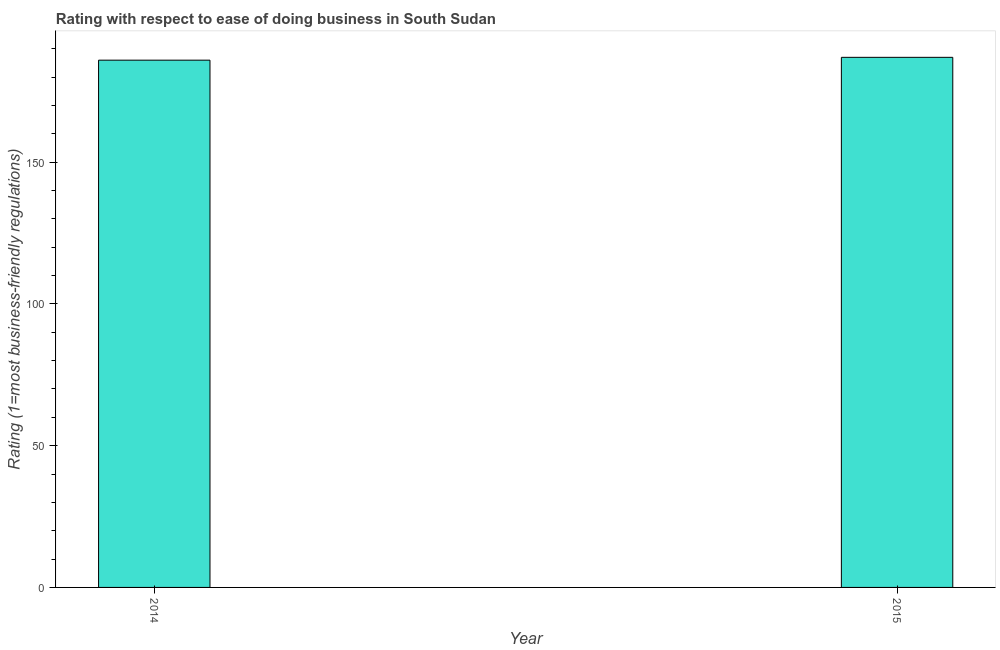Does the graph contain any zero values?
Your answer should be compact. No. Does the graph contain grids?
Offer a very short reply. No. What is the title of the graph?
Offer a terse response. Rating with respect to ease of doing business in South Sudan. What is the label or title of the X-axis?
Keep it short and to the point. Year. What is the label or title of the Y-axis?
Your answer should be very brief. Rating (1=most business-friendly regulations). What is the ease of doing business index in 2014?
Your answer should be compact. 186. Across all years, what is the maximum ease of doing business index?
Offer a terse response. 187. Across all years, what is the minimum ease of doing business index?
Give a very brief answer. 186. In which year was the ease of doing business index maximum?
Keep it short and to the point. 2015. What is the sum of the ease of doing business index?
Your answer should be compact. 373. What is the average ease of doing business index per year?
Provide a short and direct response. 186. What is the median ease of doing business index?
Offer a very short reply. 186.5. Do a majority of the years between 2015 and 2014 (inclusive) have ease of doing business index greater than 80 ?
Provide a short and direct response. No. What is the ratio of the ease of doing business index in 2014 to that in 2015?
Give a very brief answer. 0.99. Are all the bars in the graph horizontal?
Your answer should be very brief. No. What is the difference between two consecutive major ticks on the Y-axis?
Provide a succinct answer. 50. Are the values on the major ticks of Y-axis written in scientific E-notation?
Your answer should be compact. No. What is the Rating (1=most business-friendly regulations) of 2014?
Your answer should be compact. 186. What is the Rating (1=most business-friendly regulations) of 2015?
Provide a succinct answer. 187. What is the difference between the Rating (1=most business-friendly regulations) in 2014 and 2015?
Give a very brief answer. -1. What is the ratio of the Rating (1=most business-friendly regulations) in 2014 to that in 2015?
Give a very brief answer. 0.99. 